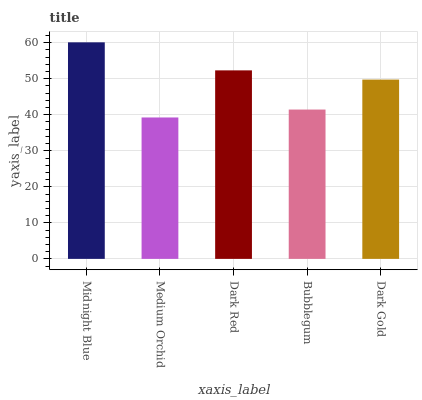Is Medium Orchid the minimum?
Answer yes or no. Yes. Is Midnight Blue the maximum?
Answer yes or no. Yes. Is Dark Red the minimum?
Answer yes or no. No. Is Dark Red the maximum?
Answer yes or no. No. Is Dark Red greater than Medium Orchid?
Answer yes or no. Yes. Is Medium Orchid less than Dark Red?
Answer yes or no. Yes. Is Medium Orchid greater than Dark Red?
Answer yes or no. No. Is Dark Red less than Medium Orchid?
Answer yes or no. No. Is Dark Gold the high median?
Answer yes or no. Yes. Is Dark Gold the low median?
Answer yes or no. Yes. Is Midnight Blue the high median?
Answer yes or no. No. Is Midnight Blue the low median?
Answer yes or no. No. 